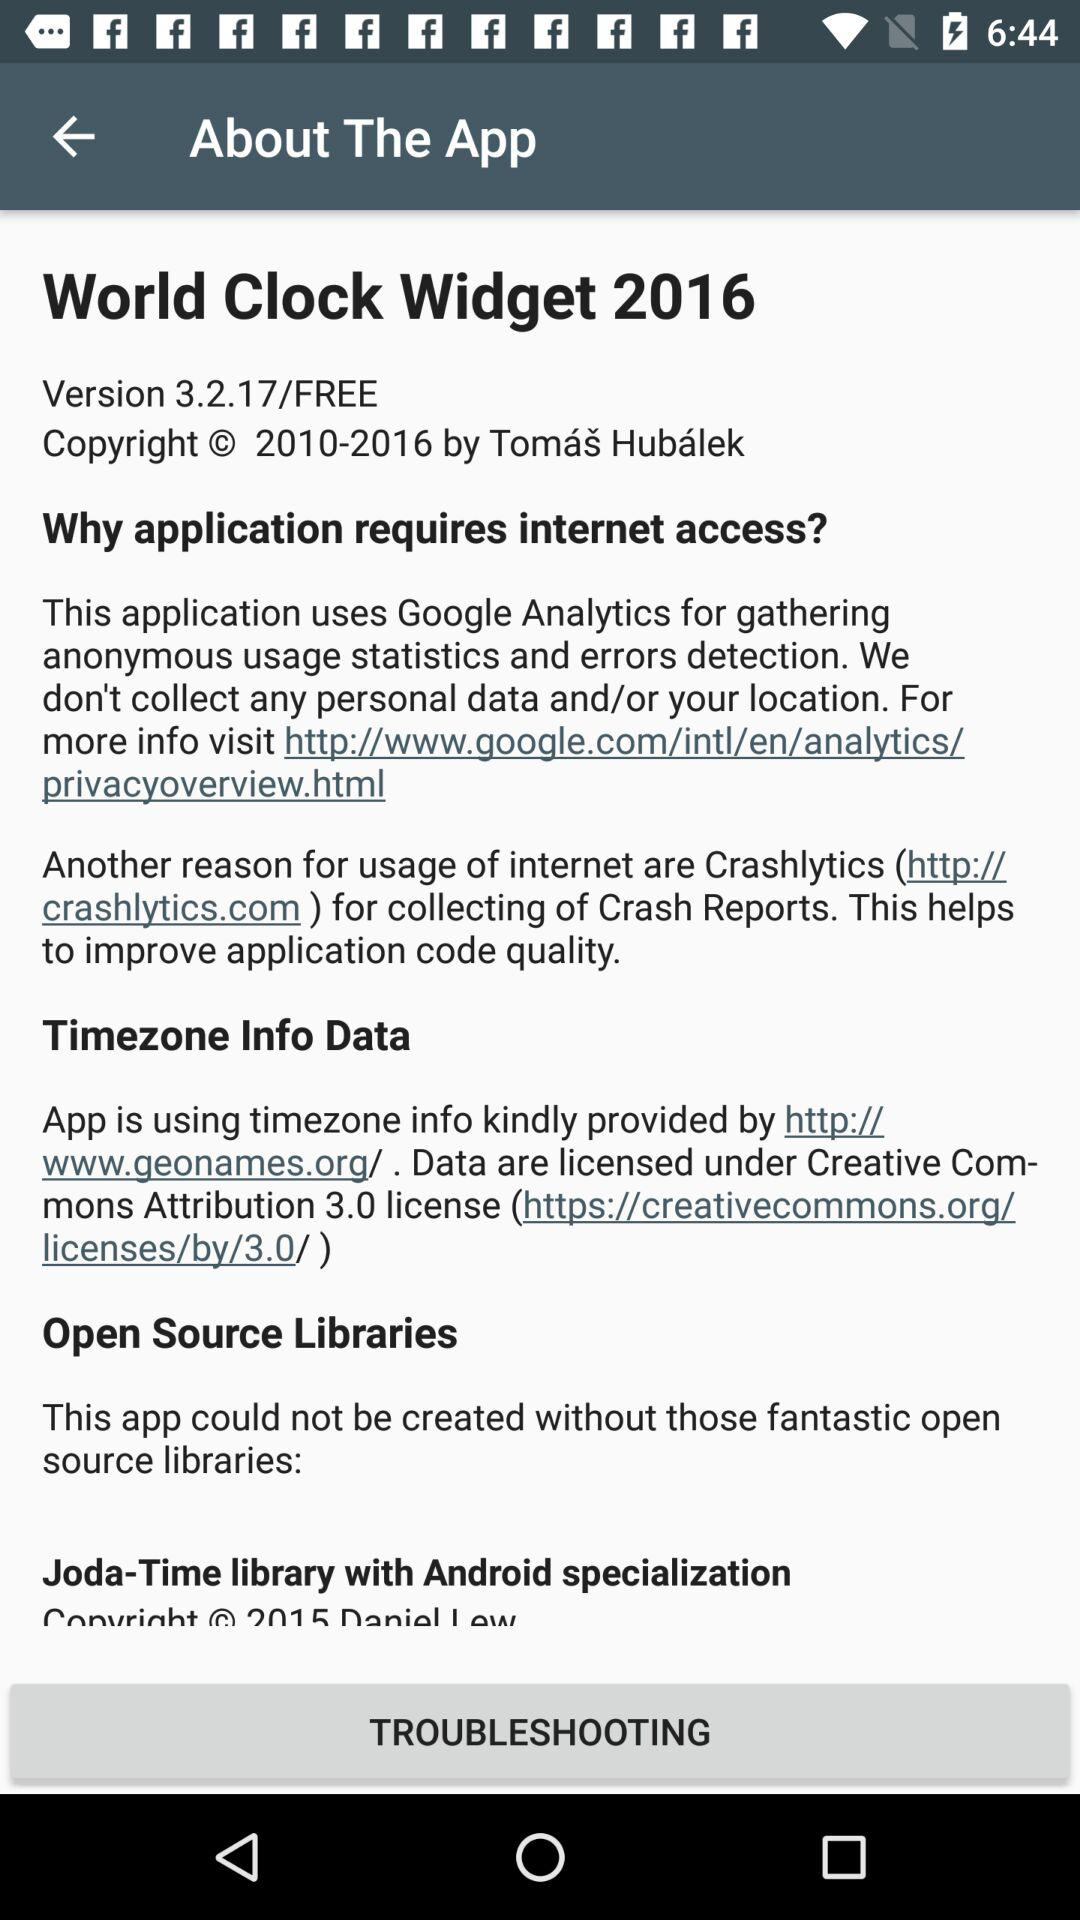What is the app that uses "Timezone info Data"? The app is "World Clock Widget 2016". 